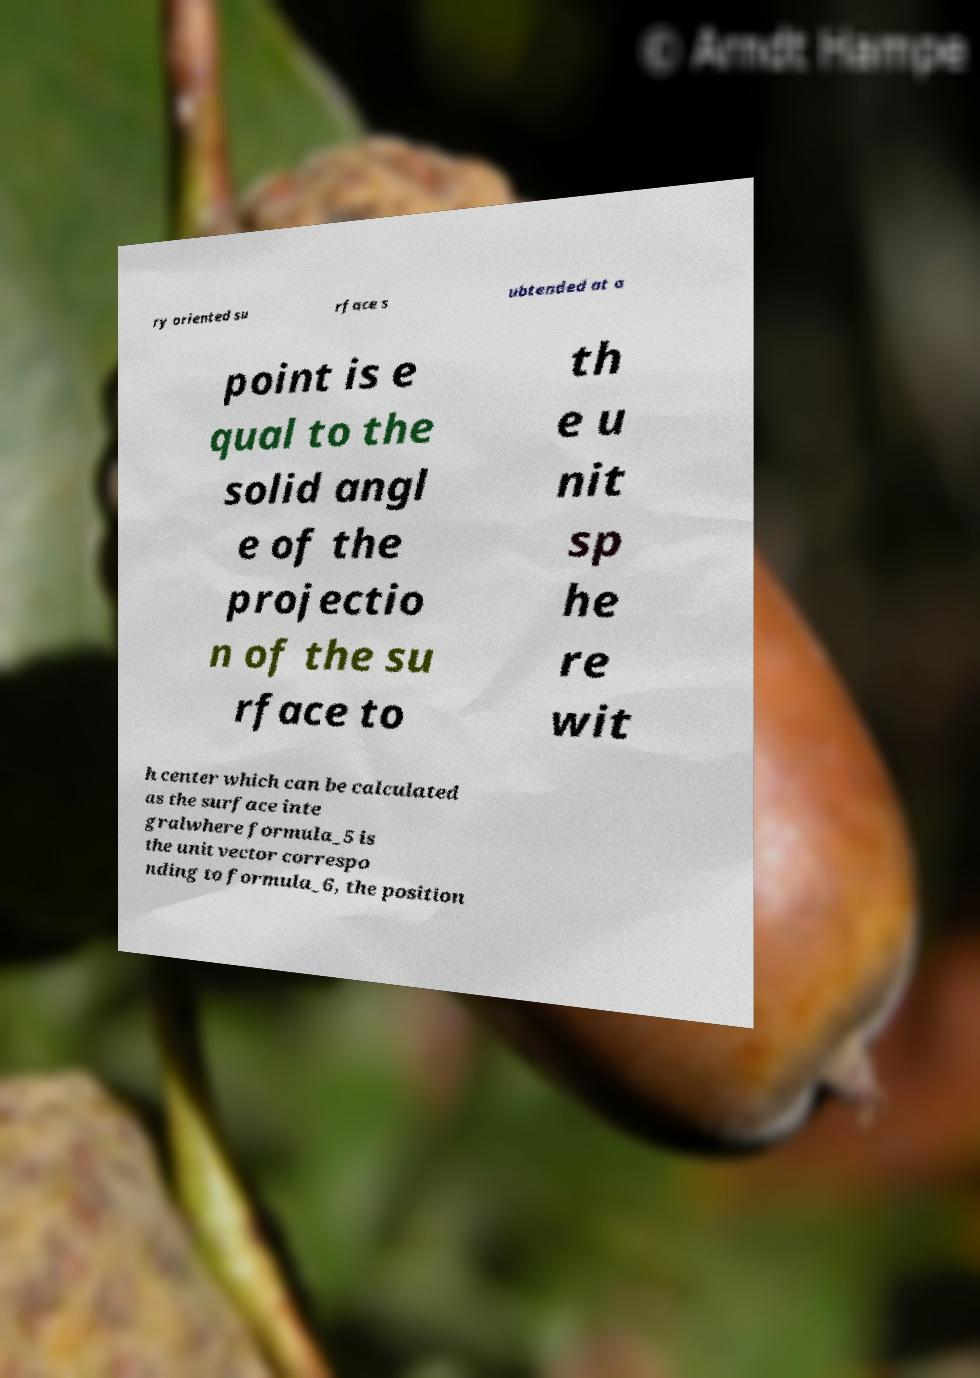Could you extract and type out the text from this image? ry oriented su rface s ubtended at a point is e qual to the solid angl e of the projectio n of the su rface to th e u nit sp he re wit h center which can be calculated as the surface inte gralwhere formula_5 is the unit vector correspo nding to formula_6, the position 